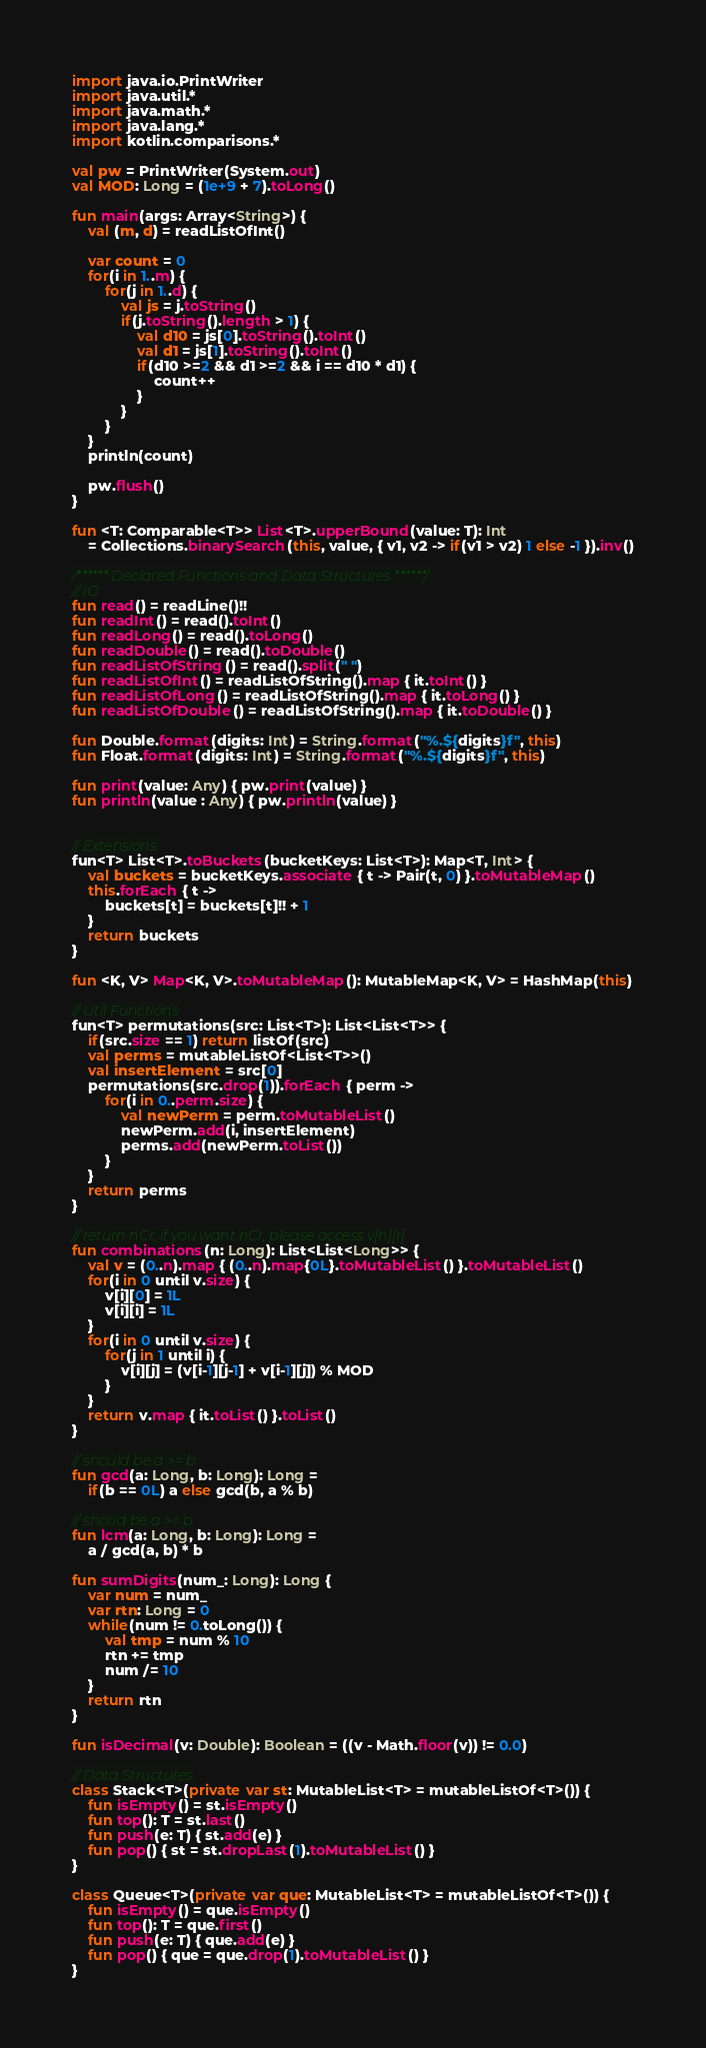Convert code to text. <code><loc_0><loc_0><loc_500><loc_500><_Kotlin_>import java.io.PrintWriter
import java.util.*
import java.math.*
import java.lang.*
import kotlin.comparisons.*

val pw = PrintWriter(System.out)
val MOD: Long = (1e+9 + 7).toLong()

fun main(args: Array<String>) {
    val (m, d) = readListOfInt()      

    var count = 0
    for(i in 1..m) {
        for(j in 1..d) {
            val js = j.toString()
            if(j.toString().length > 1) {
                val d10 = js[0].toString().toInt()
                val d1 = js[1].toString().toInt()
                if(d10 >=2 && d1 >=2 && i == d10 * d1) {
                    count++
                }
            }
        }
    }
    println(count)
    
    pw.flush()
}

fun <T: Comparable<T>> List<T>.upperBound(value: T): Int
    = Collections.binarySearch(this, value, { v1, v2 -> if(v1 > v2) 1 else -1 }).inv()

/****** Declared Functions and Data Structures ******/
// IO
fun read() = readLine()!!
fun readInt() = read().toInt()
fun readLong() = read().toLong()
fun readDouble() = read().toDouble()
fun readListOfString() = read().split(" ")
fun readListOfInt() = readListOfString().map { it.toInt() }
fun readListOfLong() = readListOfString().map { it.toLong() }
fun readListOfDouble() = readListOfString().map { it.toDouble() }

fun Double.format(digits: Int) = String.format("%.${digits}f", this)
fun Float.format(digits: Int) = String.format("%.${digits}f", this)

fun print(value: Any) { pw.print(value) }
fun println(value : Any) { pw.println(value) }


// Extensions
fun<T> List<T>.toBuckets(bucketKeys: List<T>): Map<T, Int> {
    val buckets = bucketKeys.associate { t -> Pair(t, 0) }.toMutableMap()
    this.forEach { t ->
        buckets[t] = buckets[t]!! + 1
    }
    return buckets
}

fun <K, V> Map<K, V>.toMutableMap(): MutableMap<K, V> = HashMap(this)

// Util Functions
fun<T> permutations(src: List<T>): List<List<T>> {
    if(src.size == 1) return listOf(src)
    val perms = mutableListOf<List<T>>()
    val insertElement = src[0]
    permutations(src.drop(1)).forEach { perm ->
        for(i in 0..perm.size) {
            val newPerm = perm.toMutableList()
            newPerm.add(i, insertElement)
            perms.add(newPerm.toList())
        }
    }
    return perms
}

// return nCr, if you want nCr, please access v[n][r]
fun combinations(n: Long): List<List<Long>> {
    val v = (0..n).map { (0..n).map{0L}.toMutableList() }.toMutableList()
    for(i in 0 until v.size) {
        v[i][0] = 1L
        v[i][i] = 1L
    }
    for(i in 0 until v.size) {
        for(j in 1 until i) {
            v[i][j] = (v[i-1][j-1] + v[i-1][j]) % MOD
        }
    }
    return v.map { it.toList() }.toList()
}

// should be a >= b
fun gcd(a: Long, b: Long): Long = 
    if(b == 0L) a else gcd(b, a % b)

// shoud be a >= b
fun lcm(a: Long, b: Long): Long = 
    a / gcd(a, b) * b

fun sumDigits(num_: Long): Long {
    var num = num_
    var rtn: Long = 0
    while(num != 0.toLong()) {
        val tmp = num % 10
        rtn += tmp
        num /= 10
    }
    return rtn
}

fun isDecimal(v: Double): Boolean = ((v - Math.floor(v)) != 0.0)

// Data Structures
class Stack<T>(private var st: MutableList<T> = mutableListOf<T>()) {
    fun isEmpty() = st.isEmpty()
    fun top(): T = st.last()
    fun push(e: T) { st.add(e) }
    fun pop() { st = st.dropLast(1).toMutableList() }
}

class Queue<T>(private var que: MutableList<T> = mutableListOf<T>()) {
    fun isEmpty() = que.isEmpty()
    fun top(): T = que.first()
    fun push(e: T) { que.add(e) }
    fun pop() { que = que.drop(1).toMutableList() }
}
</code> 